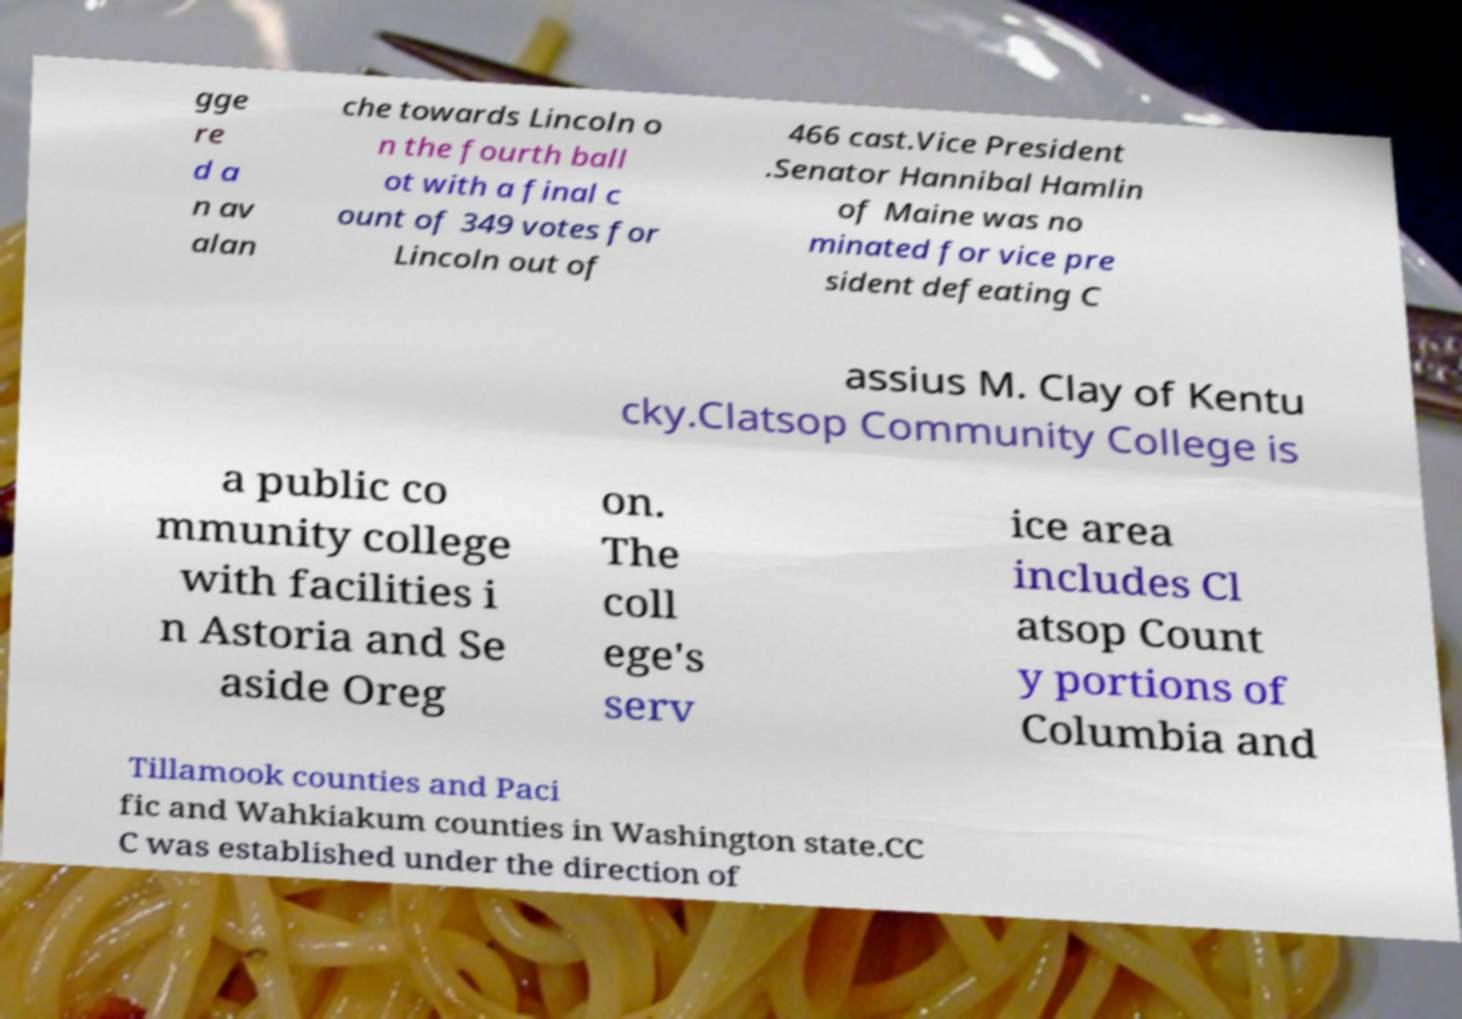Could you extract and type out the text from this image? gge re d a n av alan che towards Lincoln o n the fourth ball ot with a final c ount of 349 votes for Lincoln out of 466 cast.Vice President .Senator Hannibal Hamlin of Maine was no minated for vice pre sident defeating C assius M. Clay of Kentu cky.Clatsop Community College is a public co mmunity college with facilities i n Astoria and Se aside Oreg on. The coll ege's serv ice area includes Cl atsop Count y portions of Columbia and Tillamook counties and Paci fic and Wahkiakum counties in Washington state.CC C was established under the direction of 